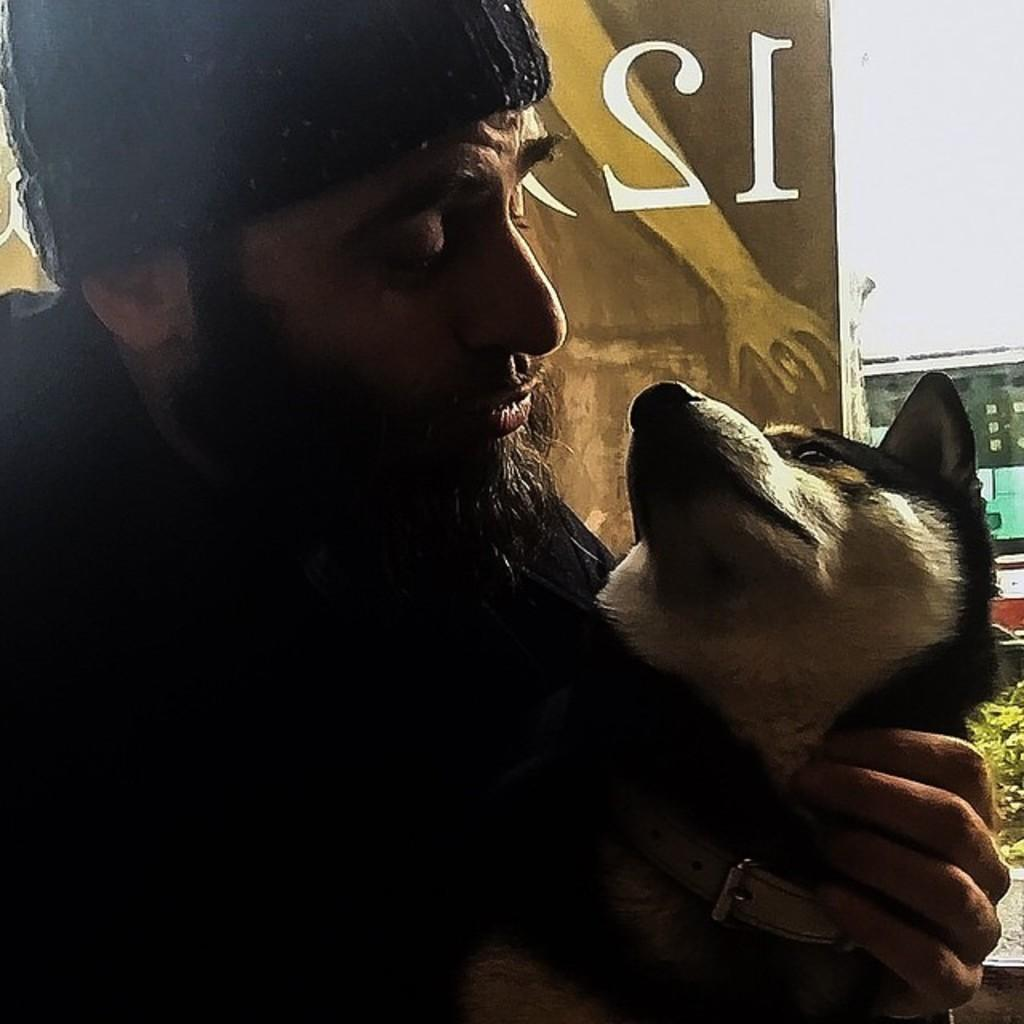Who is present in the image? There is a person in the image. What is the person wearing on their head? The person is wearing a cap. What other living creature is in the image? There is a dog in the image. What is the dog wearing around its neck? The dog is wearing a collar. What object in the image has a number on it? There is a board with a number in the image. What type of prose is being recited by the person in the image? There is no indication in the image that the person is reciting any prose. 